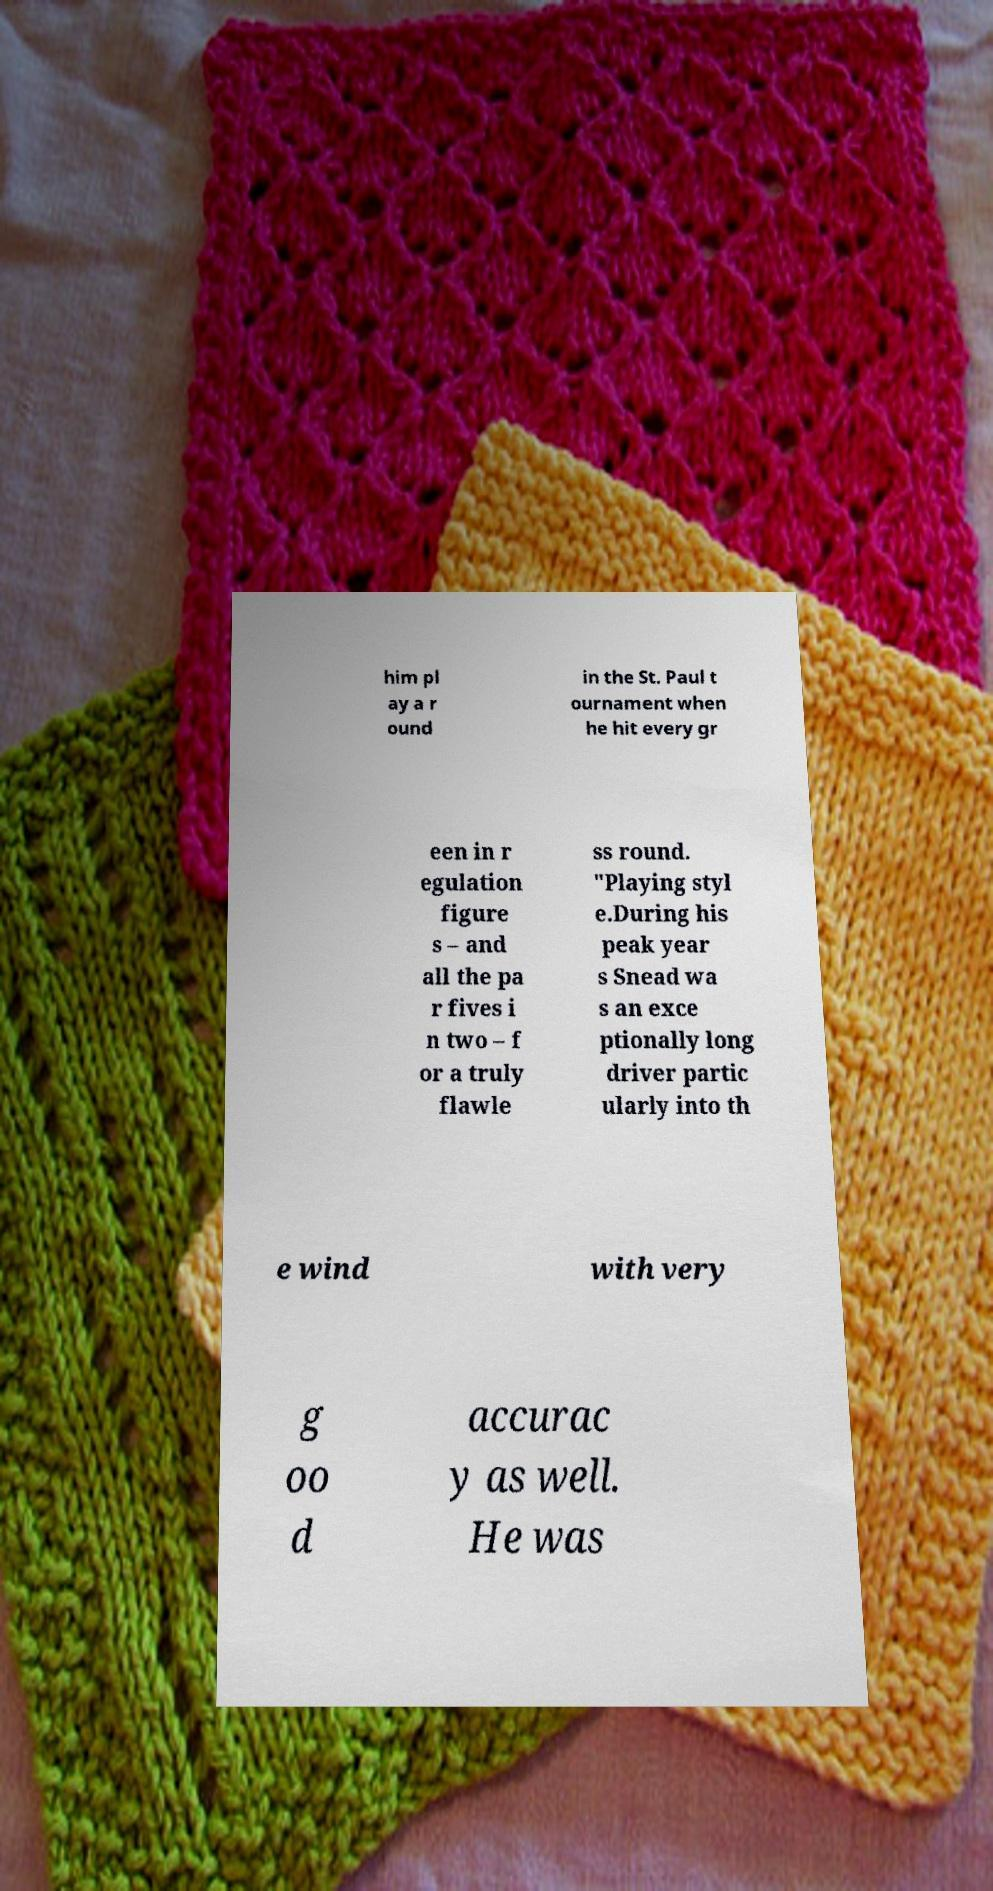What messages or text are displayed in this image? I need them in a readable, typed format. him pl ay a r ound in the St. Paul t ournament when he hit every gr een in r egulation figure s – and all the pa r fives i n two – f or a truly flawle ss round. "Playing styl e.During his peak year s Snead wa s an exce ptionally long driver partic ularly into th e wind with very g oo d accurac y as well. He was 